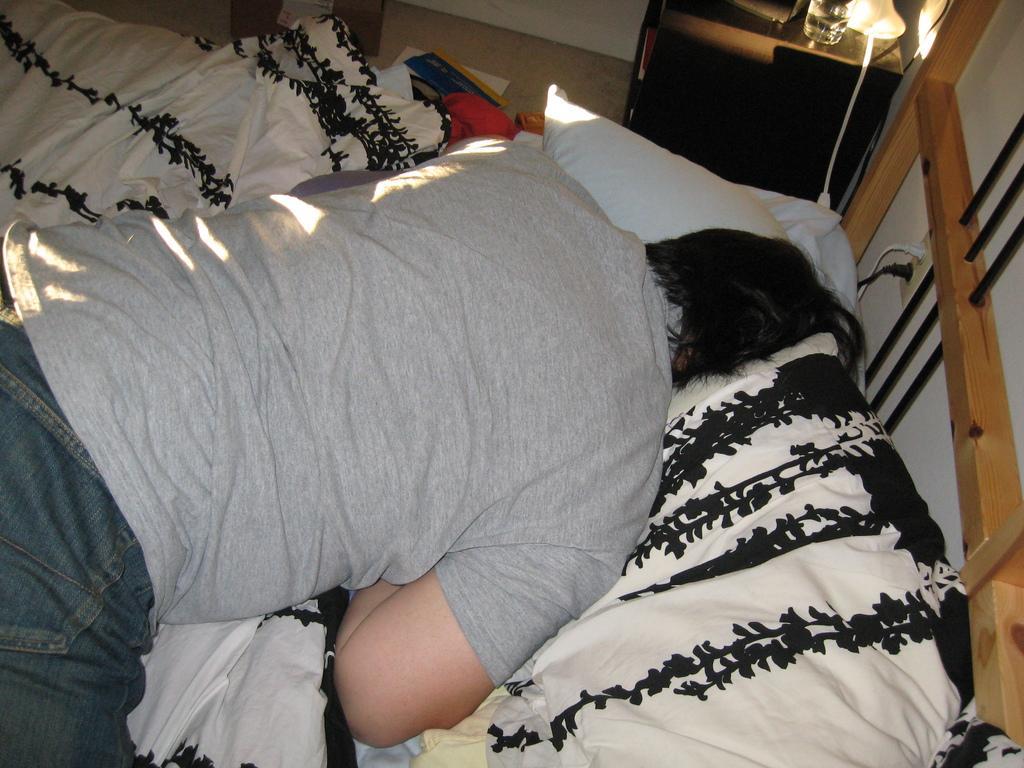Describe this image in one or two sentences. It is a bedroom, a man is laying on the bed he is sleeping beside the bed there is a lamp in the background there is a wall. 